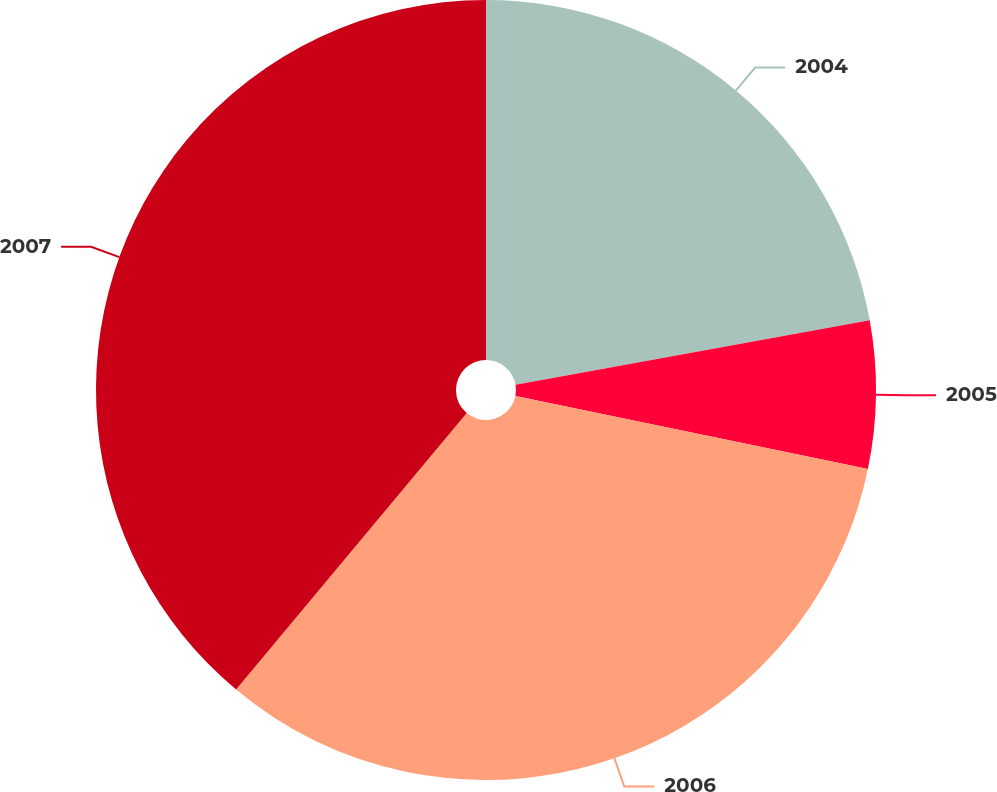Convert chart. <chart><loc_0><loc_0><loc_500><loc_500><pie_chart><fcel>2004<fcel>2005<fcel>2006<fcel>2007<nl><fcel>22.14%<fcel>6.11%<fcel>32.82%<fcel>38.93%<nl></chart> 